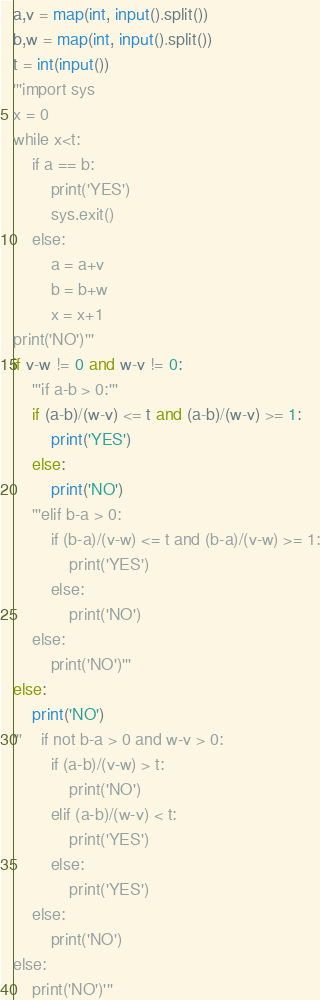<code> <loc_0><loc_0><loc_500><loc_500><_Python_>a,v = map(int, input().split())
b,w = map(int, input().split())
t = int(input())
'''import sys
x = 0
while x<t:
    if a == b:
        print('YES')
        sys.exit()
    else:
        a = a+v
        b = b+w
        x = x+1
print('NO')'''
if v-w != 0 and w-v != 0:
    '''if a-b > 0:'''
    if (a-b)/(w-v) <= t and (a-b)/(w-v) >= 1:
        print('YES')
    else:
        print('NO')
    '''elif b-a > 0:
        if (b-a)/(v-w) <= t and (b-a)/(v-w) >= 1:
            print('YES')
        else:
            print('NO')
    else:
        print('NO')'''
else:
    print('NO')
'''    if not b-a > 0 and w-v > 0:
        if (a-b)/(v-w) > t:
            print('NO')
        elif (a-b)/(w-v) < t:
            print('YES')
        else:
            print('YES')
    else:
        print('NO')
else:
    print('NO')'''
</code> 